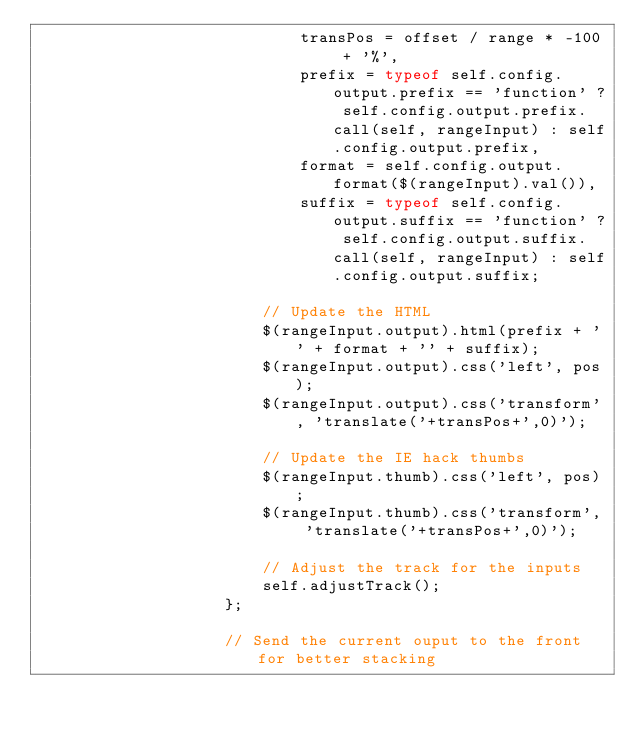Convert code to text. <code><loc_0><loc_0><loc_500><loc_500><_JavaScript_>                            transPos = offset / range * -100 + '%',
                            prefix = typeof self.config.output.prefix == 'function' ? self.config.output.prefix.call(self, rangeInput) : self.config.output.prefix,
                            format = self.config.output.format($(rangeInput).val()),
                            suffix = typeof self.config.output.suffix == 'function' ? self.config.output.suffix.call(self, rangeInput) : self.config.output.suffix;
                        
                        // Update the HTML
                        $(rangeInput.output).html(prefix + '' + format + '' + suffix);
                        $(rangeInput.output).css('left', pos);
                        $(rangeInput.output).css('transform', 'translate('+transPos+',0)');
                        
                        // Update the IE hack thumbs
                        $(rangeInput.thumb).css('left', pos);
                        $(rangeInput.thumb).css('transform', 'translate('+transPos+',0)');
                        
                        // Adjust the track for the inputs
                        self.adjustTrack();
                    };
                    
                    // Send the current ouput to the front for better stacking</code> 